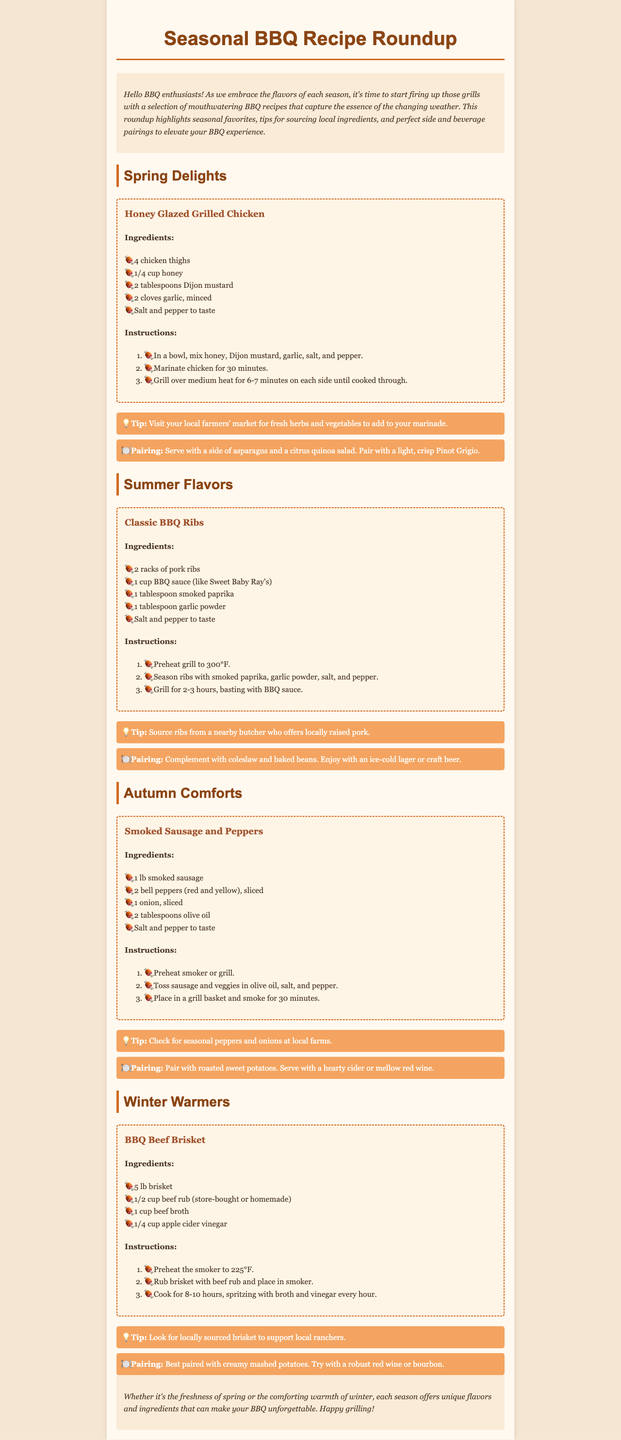What are the ingredients for Honey Glazed Grilled Chicken? The ingredients for Honey Glazed Grilled Chicken are listed in the recipe section of the document.
Answer: 4 chicken thighs, 1/4 cup honey, 2 tablespoons Dijon mustard, 2 cloves garlic, minced, salt and pepper to taste How long should you grill the pork ribs? The instructions for grilling the pork ribs specify the duration in the Summer Flavors section.
Answer: 2-3 hours What can you pair with BBQ Beef Brisket? The document suggests what to serve with BBQ Beef Brisket in the pairing section.
Answer: Creamy mashed potatoes Which season features Smoked Sausage and Peppers? The section header indicates the seasonal focus of the recipe for Smoked Sausage and Peppers.
Answer: Autumn How long should the chicken marinate for the Honey Glazed Grilled Chicken recipe? The instructions in the Spring Delights section note the marination period for the chicken.
Answer: 30 minutes What type of wine is suggested to pair with smoked sausage? The pairing section mentions the type of beverage that complements the smoked sausage dish.
Answer: Mellow red wine What is a tip for sourcing ingredients for the Honey Glazed Grilled Chicken? The tip section provides advice related to finding local ingredients for the recipe.
Answer: Visit your local farmers' market for fresh herbs and vegetables What is the main protein used in the Classic BBQ Ribs recipe? The recipe states the type of meat used in the Classic BBQ Ribs dish.
Answer: Pork ribs 